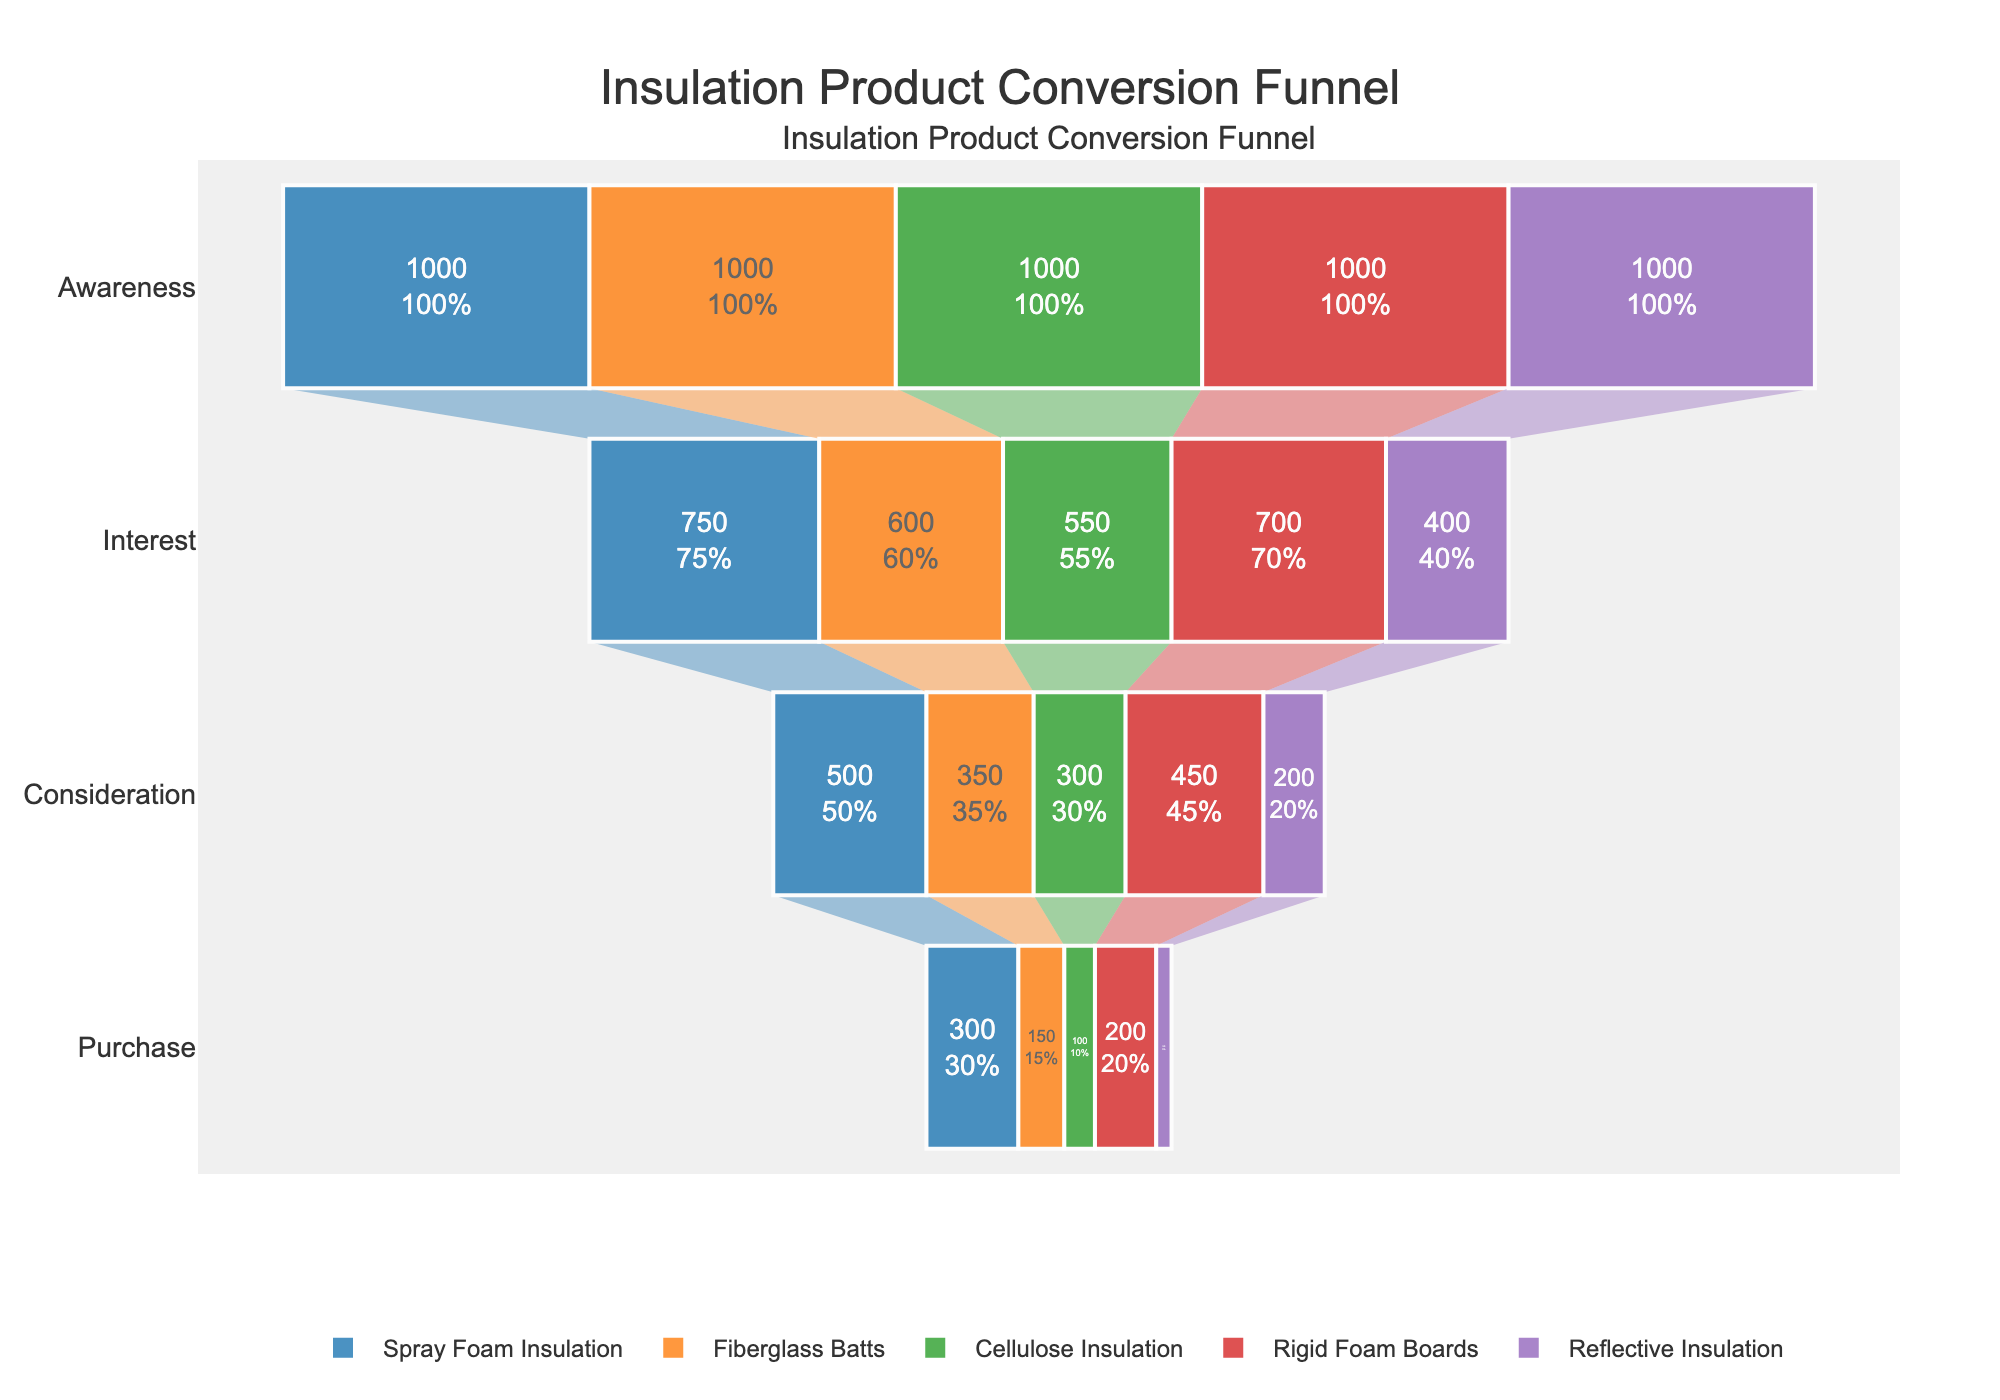What's the title of the chart? The title of the chart is located at the top and generally provides an overview of what the chart is about. In this case, it reads "Insulation Product Conversion Funnel".
Answer: Insulation Product Conversion Funnel What are the stages shown on the funnel? The stages are represented along the y-axis and typically signify different steps in the conversion process. Here, the stages are Awareness, Interest, Consideration, and Purchase.
Answer: Awareness, Interest, Consideration, Purchase How many products are being compared in the chart? Each product has its own funnel representation in the chart. Counting these representations gives us the number of products. There are five products listed.
Answer: 5 Which insulation product has the highest conversion rate at the Awareness stage? By looking at the chart, we see all products start with the same value at the Awareness stage. Thus, each product has the highest conversion rate at Awareness.
Answer: All products When comparing Spray Foam Insulation and Reflective Insulation at the Interest stage, which one has a higher count? We need to locate the values for both products at the Interest stage on the funnel chart. Spray Foam Insulation has 750 conversions, whereas Reflective Insulation has 400.
Answer: Spray Foam Insulation What is the total number of conversions for the Rigid Foam Boards across all stages? We should add the values for Rigid Foam Boards across the stages. The values are 1000 (Awareness) + 700 (Interest) + 450 (Consideration) + 200 (Purchase).
Answer: 2350 Which product has the lowest conversion rate at the Purchase stage? We check the values at the Purchase stage for each product. Reflective Insulation has the lowest with 50 conversions.
Answer: Reflective Insulation By how much does the number of conversions from Awareness to Interest stage decrease for Fiberglass Batts? Subtract the Interest stage value from the Awareness stage value for Fiberglass Batts: 1000 (Awareness) - 600 (Interest) = 400.
Answer: 400 What is the average conversion rate at the Consideration stage for all products? Calculate the average by summing the Consideration stage values for all products and dividing by the number of products: (500 + 350 + 300 + 450 + 200) / 5 = 1800 / 5.
Answer: 360 Which product shows the least drop in conversions from the Consideration to Purchase stage? Calculate the drop for each product from Consideration to Purchase: 
- Spray Foam Insulation: 500 - 300 = 200
- Fiberglass Batts: 350 - 150 = 200
- Cellulose Insulation: 300 - 100 = 200
- Rigid Foam Boards: 450 - 200 = 250
- Reflective Insulation: 200 - 50 = 150
Reflective Insulation has the least drop.
Answer: Reflective Insulation 